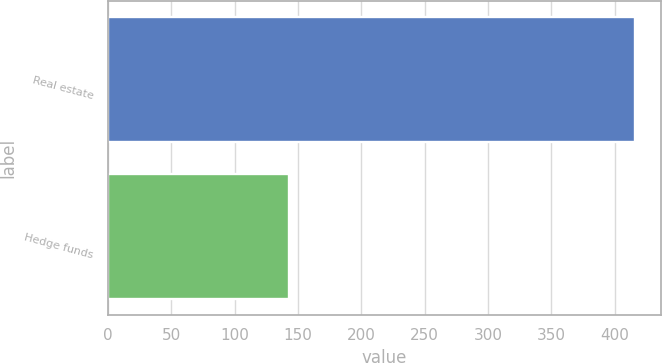Convert chart to OTSL. <chart><loc_0><loc_0><loc_500><loc_500><bar_chart><fcel>Real estate<fcel>Hedge funds<nl><fcel>416<fcel>143<nl></chart> 